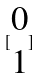Convert formula to latex. <formula><loc_0><loc_0><loc_500><loc_500>[ \begin{matrix} 0 \\ 1 \end{matrix} ]</formula> 